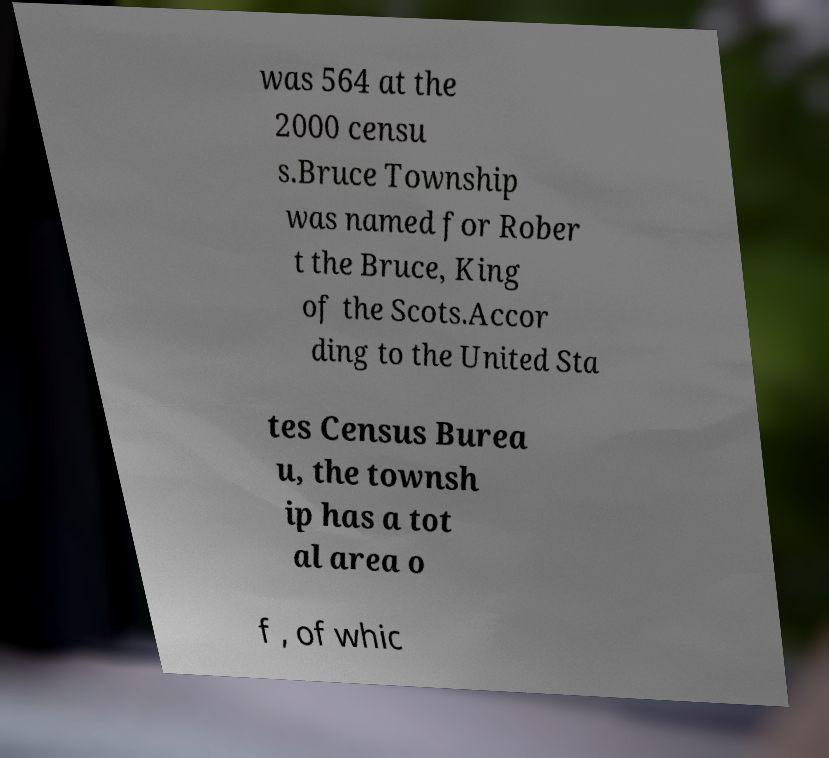Could you assist in decoding the text presented in this image and type it out clearly? was 564 at the 2000 censu s.Bruce Township was named for Rober t the Bruce, King of the Scots.Accor ding to the United Sta tes Census Burea u, the townsh ip has a tot al area o f , of whic 